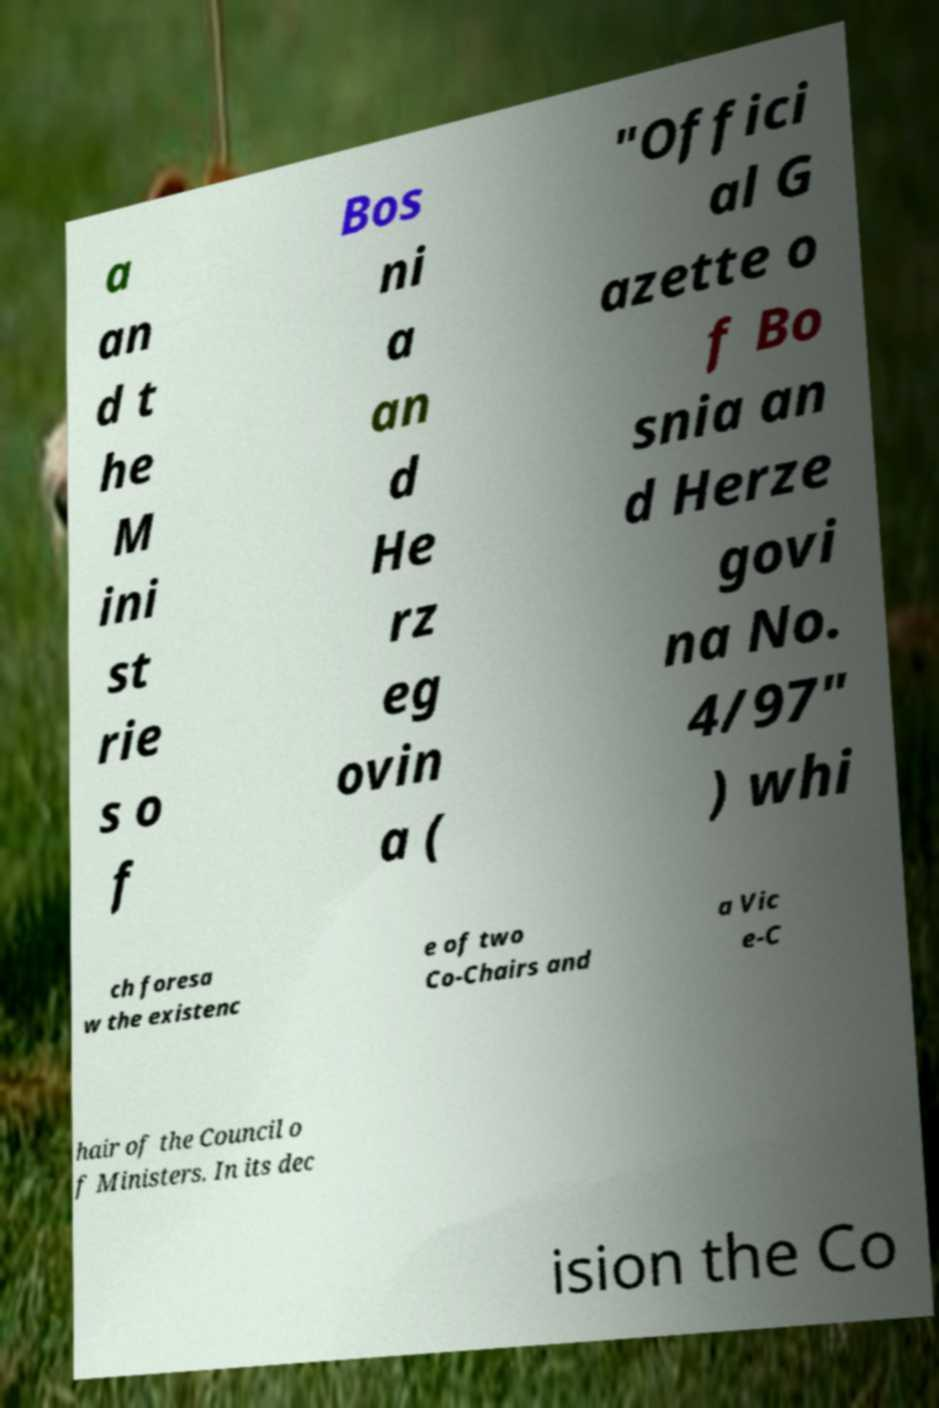I need the written content from this picture converted into text. Can you do that? a an d t he M ini st rie s o f Bos ni a an d He rz eg ovin a ( "Offici al G azette o f Bo snia an d Herze govi na No. 4/97" ) whi ch foresa w the existenc e of two Co-Chairs and a Vic e-C hair of the Council o f Ministers. In its dec ision the Co 